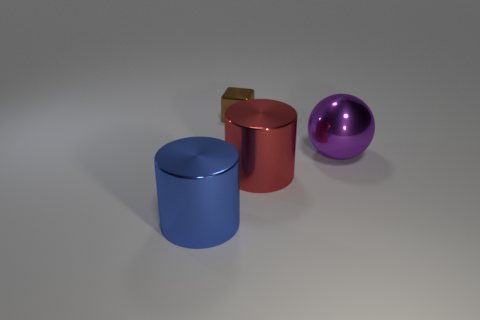Does the purple sphere have the same material as the blue thing?
Ensure brevity in your answer.  Yes. How many spheres are tiny rubber things or tiny things?
Provide a succinct answer. 0. The small cube that is the same material as the red object is what color?
Provide a succinct answer. Brown. Is the number of big red shiny things less than the number of red blocks?
Make the answer very short. No. Is the shape of the shiny object behind the big purple shiny thing the same as the large object that is behind the red metal object?
Provide a short and direct response. No. What number of objects are tiny gray matte cubes or cylinders?
Your answer should be very brief. 2. There is a sphere that is the same size as the blue shiny thing; what color is it?
Offer a terse response. Purple. How many large blue things are to the right of the shiny thing that is behind the purple metal sphere?
Make the answer very short. 0. What number of large objects are in front of the purple shiny sphere and right of the small block?
Your response must be concise. 1. How many things are either large shiny things in front of the large shiny ball or metallic objects that are in front of the ball?
Make the answer very short. 2. 